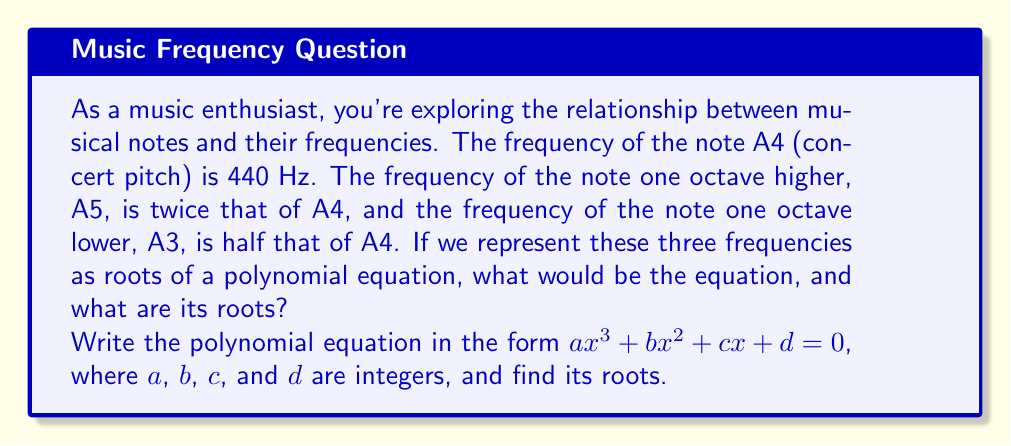Can you solve this math problem? Let's approach this step-by-step:

1) We know that the three frequencies are:
   A3: 220 Hz
   A4: 440 Hz
   A5: 880 Hz

2) We need to create a polynomial that has these three values as its roots. The general form of such a polynomial is:

   $$(x - 220)(x - 440)(x - 880) = 0$$

3) Let's expand this:
   $$(x - 220)(x^2 - 1320x + 387200) = 0$$
   $$x^3 - 1320x^2 + 387200x - 220x^2 + 290400x - 85184000 = 0$$
   $$x^3 - 1540x^2 + 677600x - 85184000 = 0$$

4) This is our polynomial equation. To put it in the required form $ax^3 + bx^2 + cx + d = 0$, we need to divide all terms by the coefficient of $x^3$, which is 1 in this case.

5) Therefore, our final equation is:

   $$x^3 - 1540x^2 + 677600x - 85184000 = 0$$

6) The roots of this equation are the original frequencies:
   220 Hz, 440 Hz, and 880 Hz
Answer: The polynomial equation is:
$$x^3 - 1540x^2 + 677600x - 85184000 = 0$$

The roots are: 220, 440, and 880. 